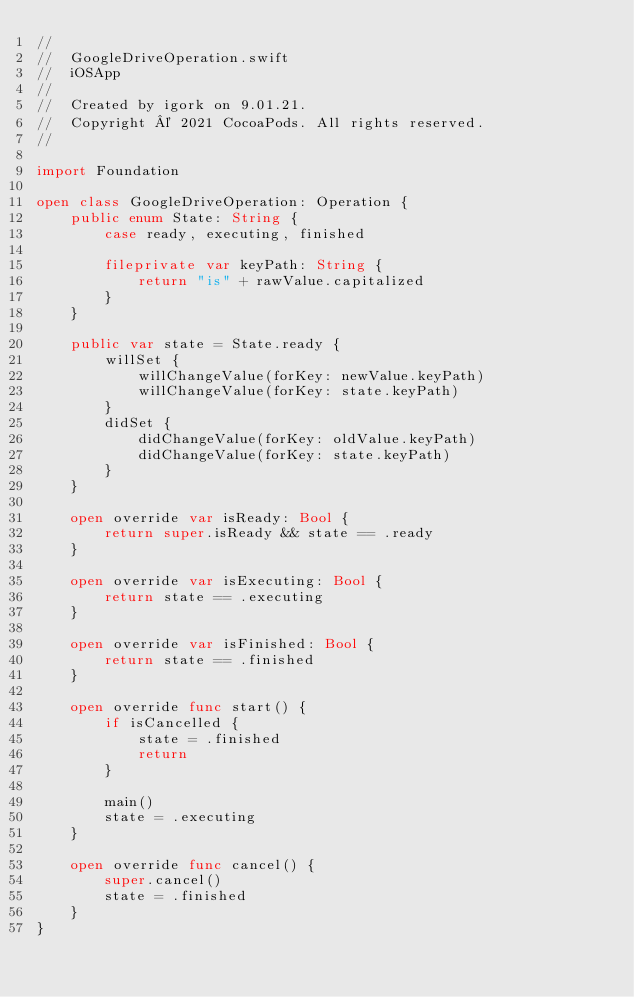Convert code to text. <code><loc_0><loc_0><loc_500><loc_500><_Swift_>//
//  GoogleDriveOperation.swift
//  iOSApp
//
//  Created by igork on 9.01.21.
//  Copyright © 2021 CocoaPods. All rights reserved.
//

import Foundation

open class GoogleDriveOperation: Operation {
    public enum State: String {
        case ready, executing, finished

        fileprivate var keyPath: String {
            return "is" + rawValue.capitalized
        }
    }

    public var state = State.ready {
        willSet {
            willChangeValue(forKey: newValue.keyPath)
            willChangeValue(forKey: state.keyPath)
        }
        didSet {
            didChangeValue(forKey: oldValue.keyPath)
            didChangeValue(forKey: state.keyPath)
        }
    }

    open override var isReady: Bool {
        return super.isReady && state == .ready
    }

    open override var isExecuting: Bool {
        return state == .executing
    }

    open override var isFinished: Bool {
        return state == .finished
    }

    open override func start() {
        if isCancelled {
            state = .finished
            return
        }

        main()
        state = .executing
    }

    open override func cancel() {
        super.cancel()
        state = .finished
    }
}
</code> 